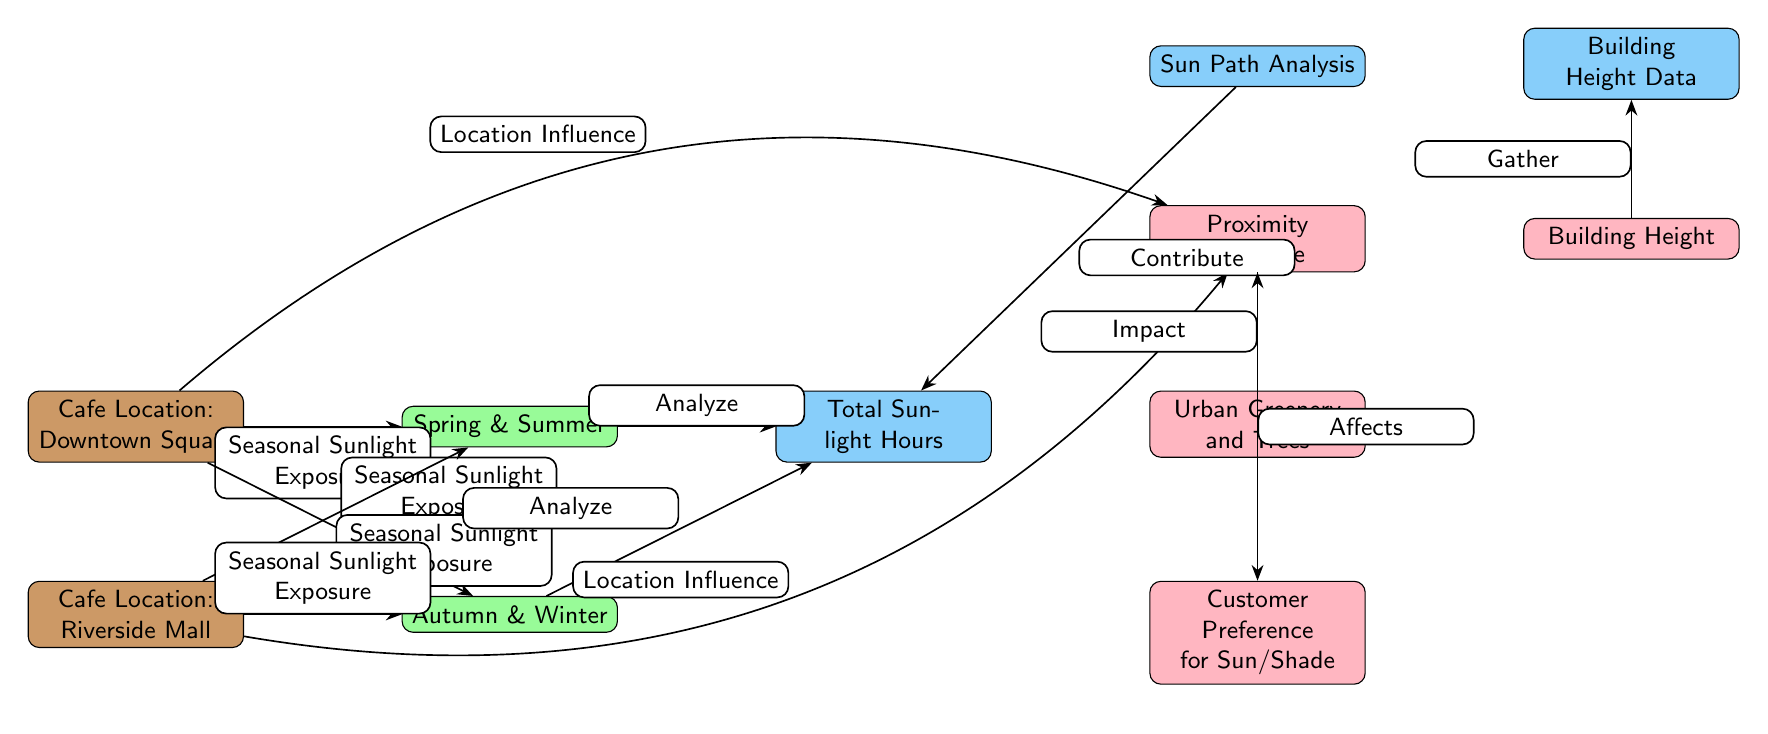What are the two cafe locations mentioned in the diagram? The diagram explicitly lists two cafe locations: Downtown Square and Riverside Mall. These are directly stated in the nodes labeled for each cafe location.
Answer: Downtown Square, Riverside Mall How many main sections does this diagram have? The diagram prominently has three main sections: cafe locations, seasonal sunlight exposure, and analysis/factors that influence sunlight exposure. This can be identified from the distinct node groups shown in the diagram.
Answer: Three What seasonal sunlight exposure is associated with Downtown Square? The diagram connects Downtown Square to both Spring and Summer for seasonal sunlight exposure, indicated by the edges leading to those nodes.
Answer: Spring & Summer What node directly affects customer preference? The node labeled "Proximity to Shade" directly affects customer preference for sun/shade, as indicated by the edge leading from it to the "Customer Preference for Sun/Shade" node.
Answer: Proximity to Shade How does building height data relate to the analysis of sunlight exposure? The "Building Height Data" node is connected to the "Building Height" node, which suggests that it is gathered to understand its influence on the analysis of sunlight exposure, showing a direct relationship.
Answer: Gathers data What two factors influence the analysis of total sunlight hours? The two factors influencing total sunlight hours are "Sun Path Analysis" and "Urban Greenery and Trees," both indicated by their connecting edges to the "Total Sunlight Hours" node.
Answer: Sun Path Analysis, Urban Greenery and Trees Which cafe location shows a direct influence from the proximity to shade? Both cafe locations, Downtown Square and Riverside Mall, have a connection to the "Proximity to Shade," but only one can have a direct influence on it. Visiting the nodes suggests Downtown Square is closer in edge orientation, thus showing a more direct influence.
Answer: Downtown Square What is the implication of the edges labeled "Seasonal Sunlight Exposure"? The edges labeled "Seasonal Sunlight Exposure" illustrate that both cafe locations are analyzed for how season changes affect the sunlight they receive throughout the year, indicating a timeline for exposure.
Answer: Analyze seasonal effects 